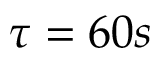<formula> <loc_0><loc_0><loc_500><loc_500>\tau = 6 0 s</formula> 